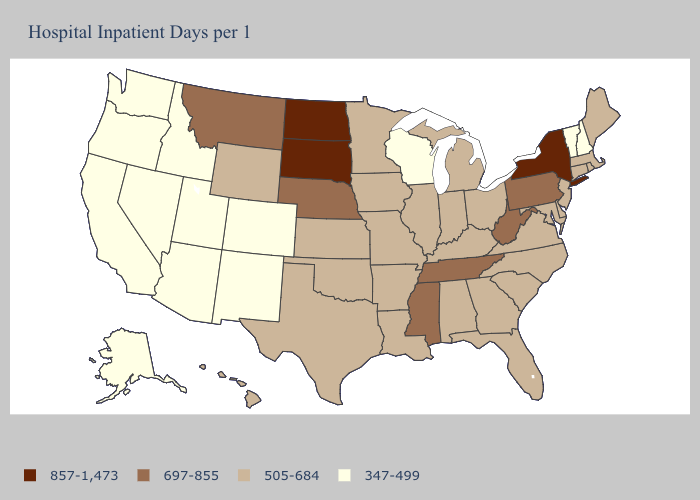Among the states that border Montana , which have the lowest value?
Be succinct. Idaho. Does Ohio have the highest value in the MidWest?
Quick response, please. No. Which states have the lowest value in the MidWest?
Answer briefly. Wisconsin. What is the value of Delaware?
Write a very short answer. 505-684. Does Mississippi have the highest value in the South?
Concise answer only. Yes. What is the value of Ohio?
Write a very short answer. 505-684. Name the states that have a value in the range 347-499?
Short answer required. Alaska, Arizona, California, Colorado, Idaho, Nevada, New Hampshire, New Mexico, Oregon, Utah, Vermont, Washington, Wisconsin. Which states have the lowest value in the South?
Short answer required. Alabama, Arkansas, Delaware, Florida, Georgia, Kentucky, Louisiana, Maryland, North Carolina, Oklahoma, South Carolina, Texas, Virginia. Does the map have missing data?
Keep it brief. No. What is the value of Nevada?
Write a very short answer. 347-499. What is the lowest value in states that border South Dakota?
Write a very short answer. 505-684. What is the value of Wyoming?
Give a very brief answer. 505-684. What is the value of Connecticut?
Answer briefly. 505-684. Which states have the lowest value in the South?
Keep it brief. Alabama, Arkansas, Delaware, Florida, Georgia, Kentucky, Louisiana, Maryland, North Carolina, Oklahoma, South Carolina, Texas, Virginia. Which states have the lowest value in the USA?
Be succinct. Alaska, Arizona, California, Colorado, Idaho, Nevada, New Hampshire, New Mexico, Oregon, Utah, Vermont, Washington, Wisconsin. 